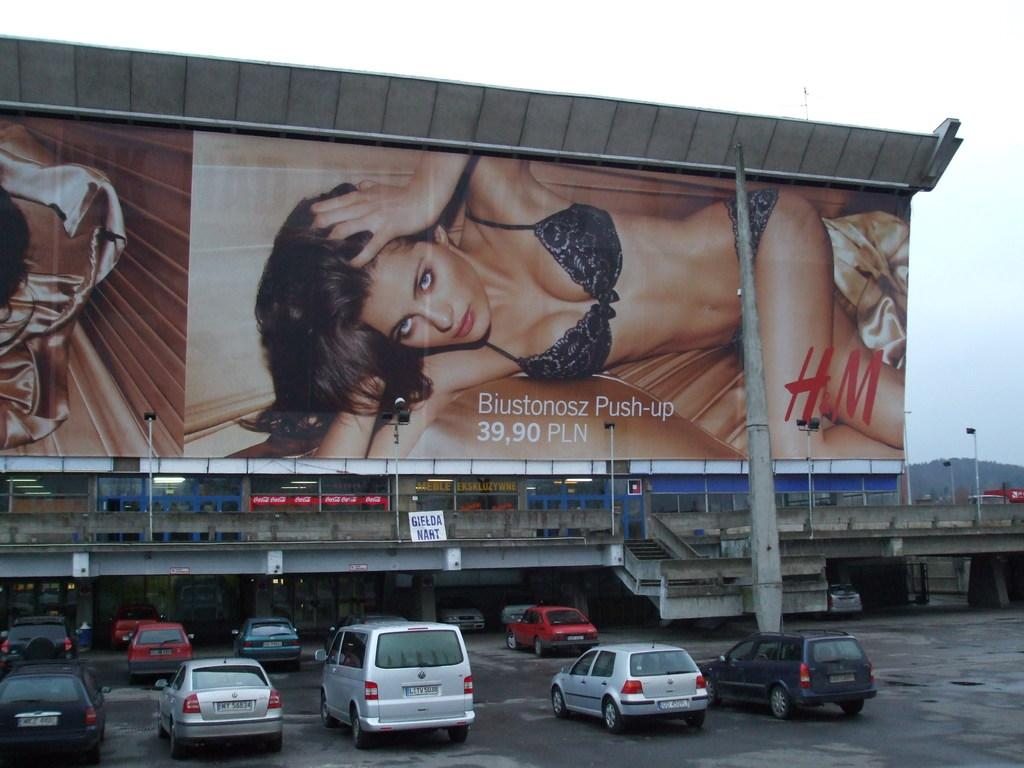Provide a one-sentence caption for the provided image. An H&M ad for a Biustonosz Push-up for 39,90 PLN displayed over a parking lot. 